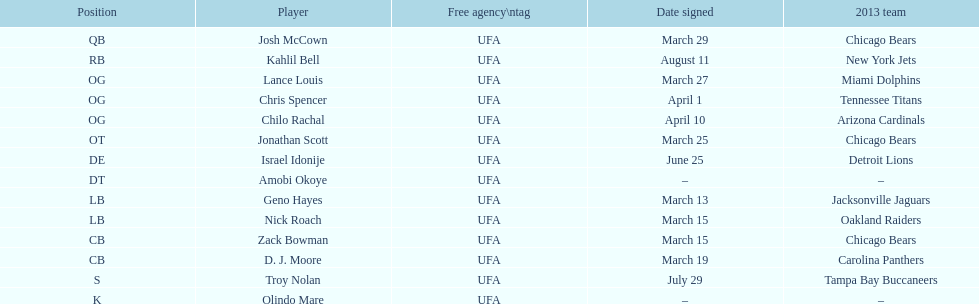How many players play cb or og? 5. 